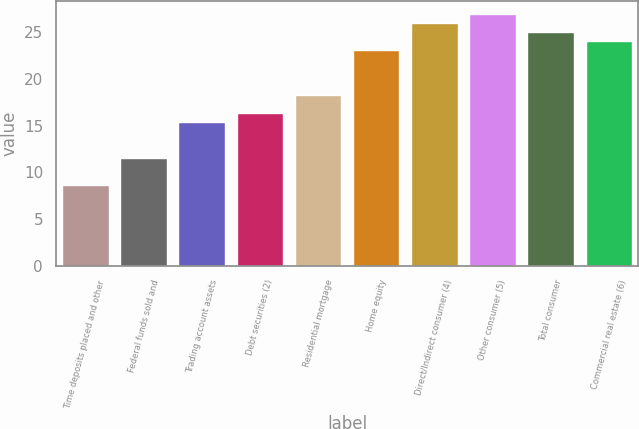Convert chart. <chart><loc_0><loc_0><loc_500><loc_500><bar_chart><fcel>Time deposits placed and other<fcel>Federal funds sold and<fcel>Trading account assets<fcel>Debt securities (2)<fcel>Residential mortgage<fcel>Home equity<fcel>Direct/Indirect consumer (4)<fcel>Other consumer (5)<fcel>Total consumer<fcel>Commercial real estate (6)<nl><fcel>8.59<fcel>11.5<fcel>15.38<fcel>16.35<fcel>18.29<fcel>23.14<fcel>26.05<fcel>27.02<fcel>25.08<fcel>24.11<nl></chart> 